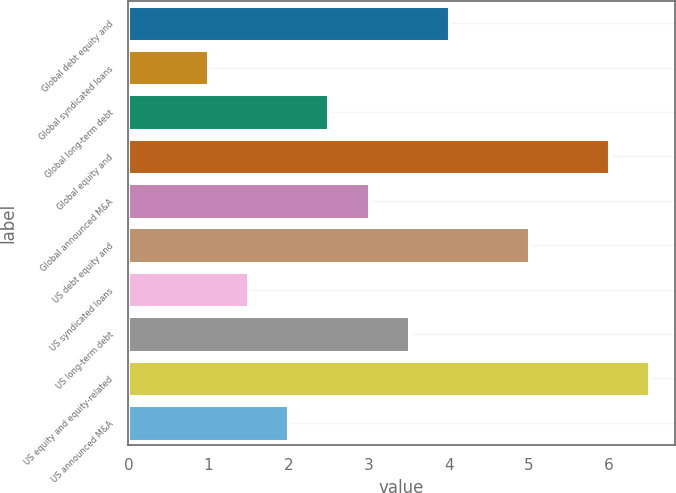<chart> <loc_0><loc_0><loc_500><loc_500><bar_chart><fcel>Global debt equity and<fcel>Global syndicated loans<fcel>Global long-term debt<fcel>Global equity and<fcel>Global announced M&A<fcel>US debt equity and<fcel>US syndicated loans<fcel>US long-term debt<fcel>US equity and equity-related<fcel>US announced M&A<nl><fcel>4<fcel>1<fcel>2.5<fcel>6<fcel>3<fcel>5<fcel>1.5<fcel>3.5<fcel>6.5<fcel>2<nl></chart> 